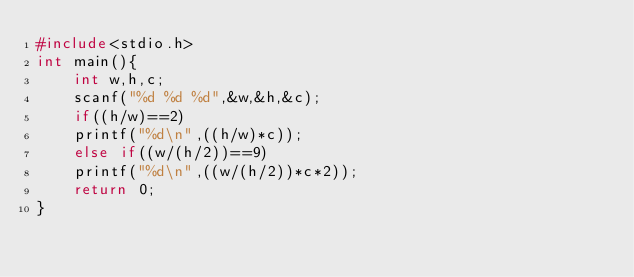<code> <loc_0><loc_0><loc_500><loc_500><_C_>#include<stdio.h>
int main(){
	int w,h,c;
	scanf("%d %d %d",&w,&h,&c);
	if((h/w)==2)
	printf("%d\n",((h/w)*c));
	else if((w/(h/2))==9)
	printf("%d\n",((w/(h/2))*c*2));
	return 0;
}</code> 